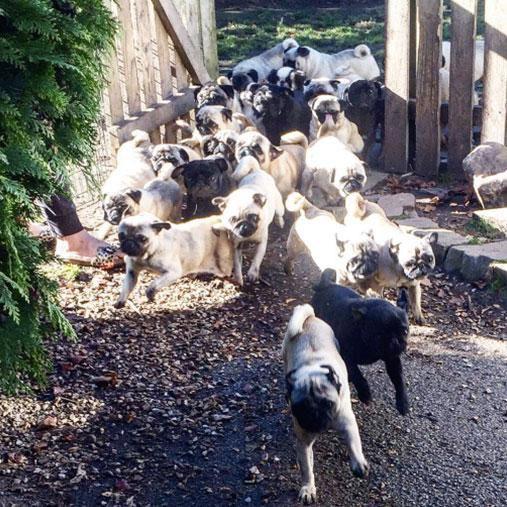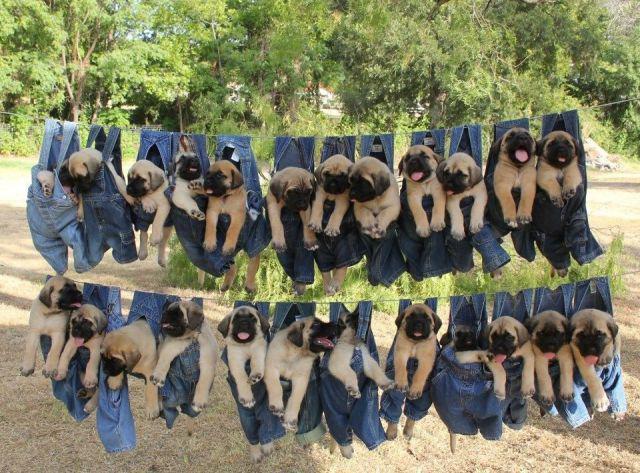The first image is the image on the left, the second image is the image on the right. Given the left and right images, does the statement "The dog on the left is near an area of water." hold true? Answer yes or no. No. The first image is the image on the left, the second image is the image on the right. Considering the images on both sides, is "Exactly one pug dog is shown in a scene with water." valid? Answer yes or no. No. 